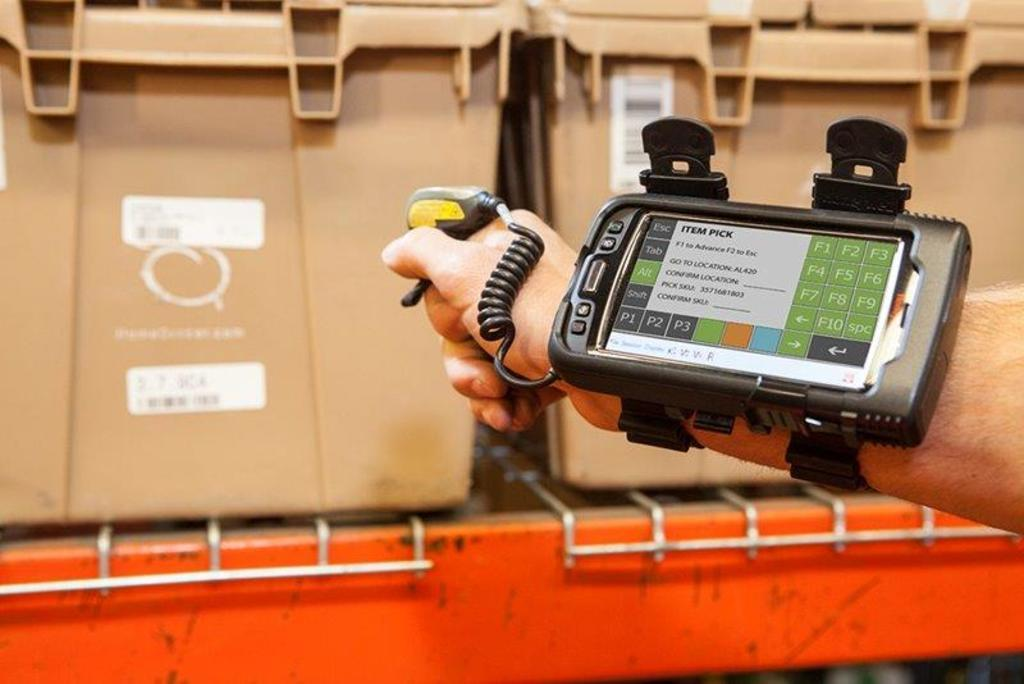<image>
Create a compact narrative representing the image presented. a person with a cell phone reading ITEM PICK attached to their arm aims at a target 